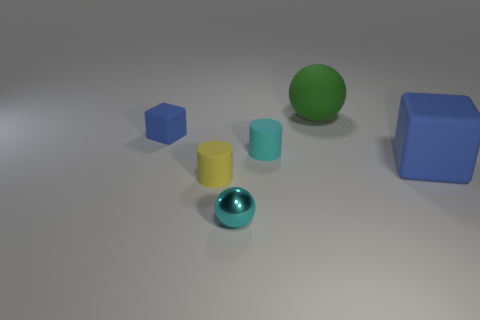Add 4 small blue things. How many objects exist? 10 Subtract all cyan cylinders. How many cylinders are left? 1 Subtract all balls. How many objects are left? 4 Subtract 1 cubes. How many cubes are left? 1 Add 6 cyan things. How many cyan things exist? 8 Subtract 0 yellow spheres. How many objects are left? 6 Subtract all brown cylinders. Subtract all blue spheres. How many cylinders are left? 2 Subtract all tiny metal spheres. Subtract all big green spheres. How many objects are left? 4 Add 3 tiny cubes. How many tiny cubes are left? 4 